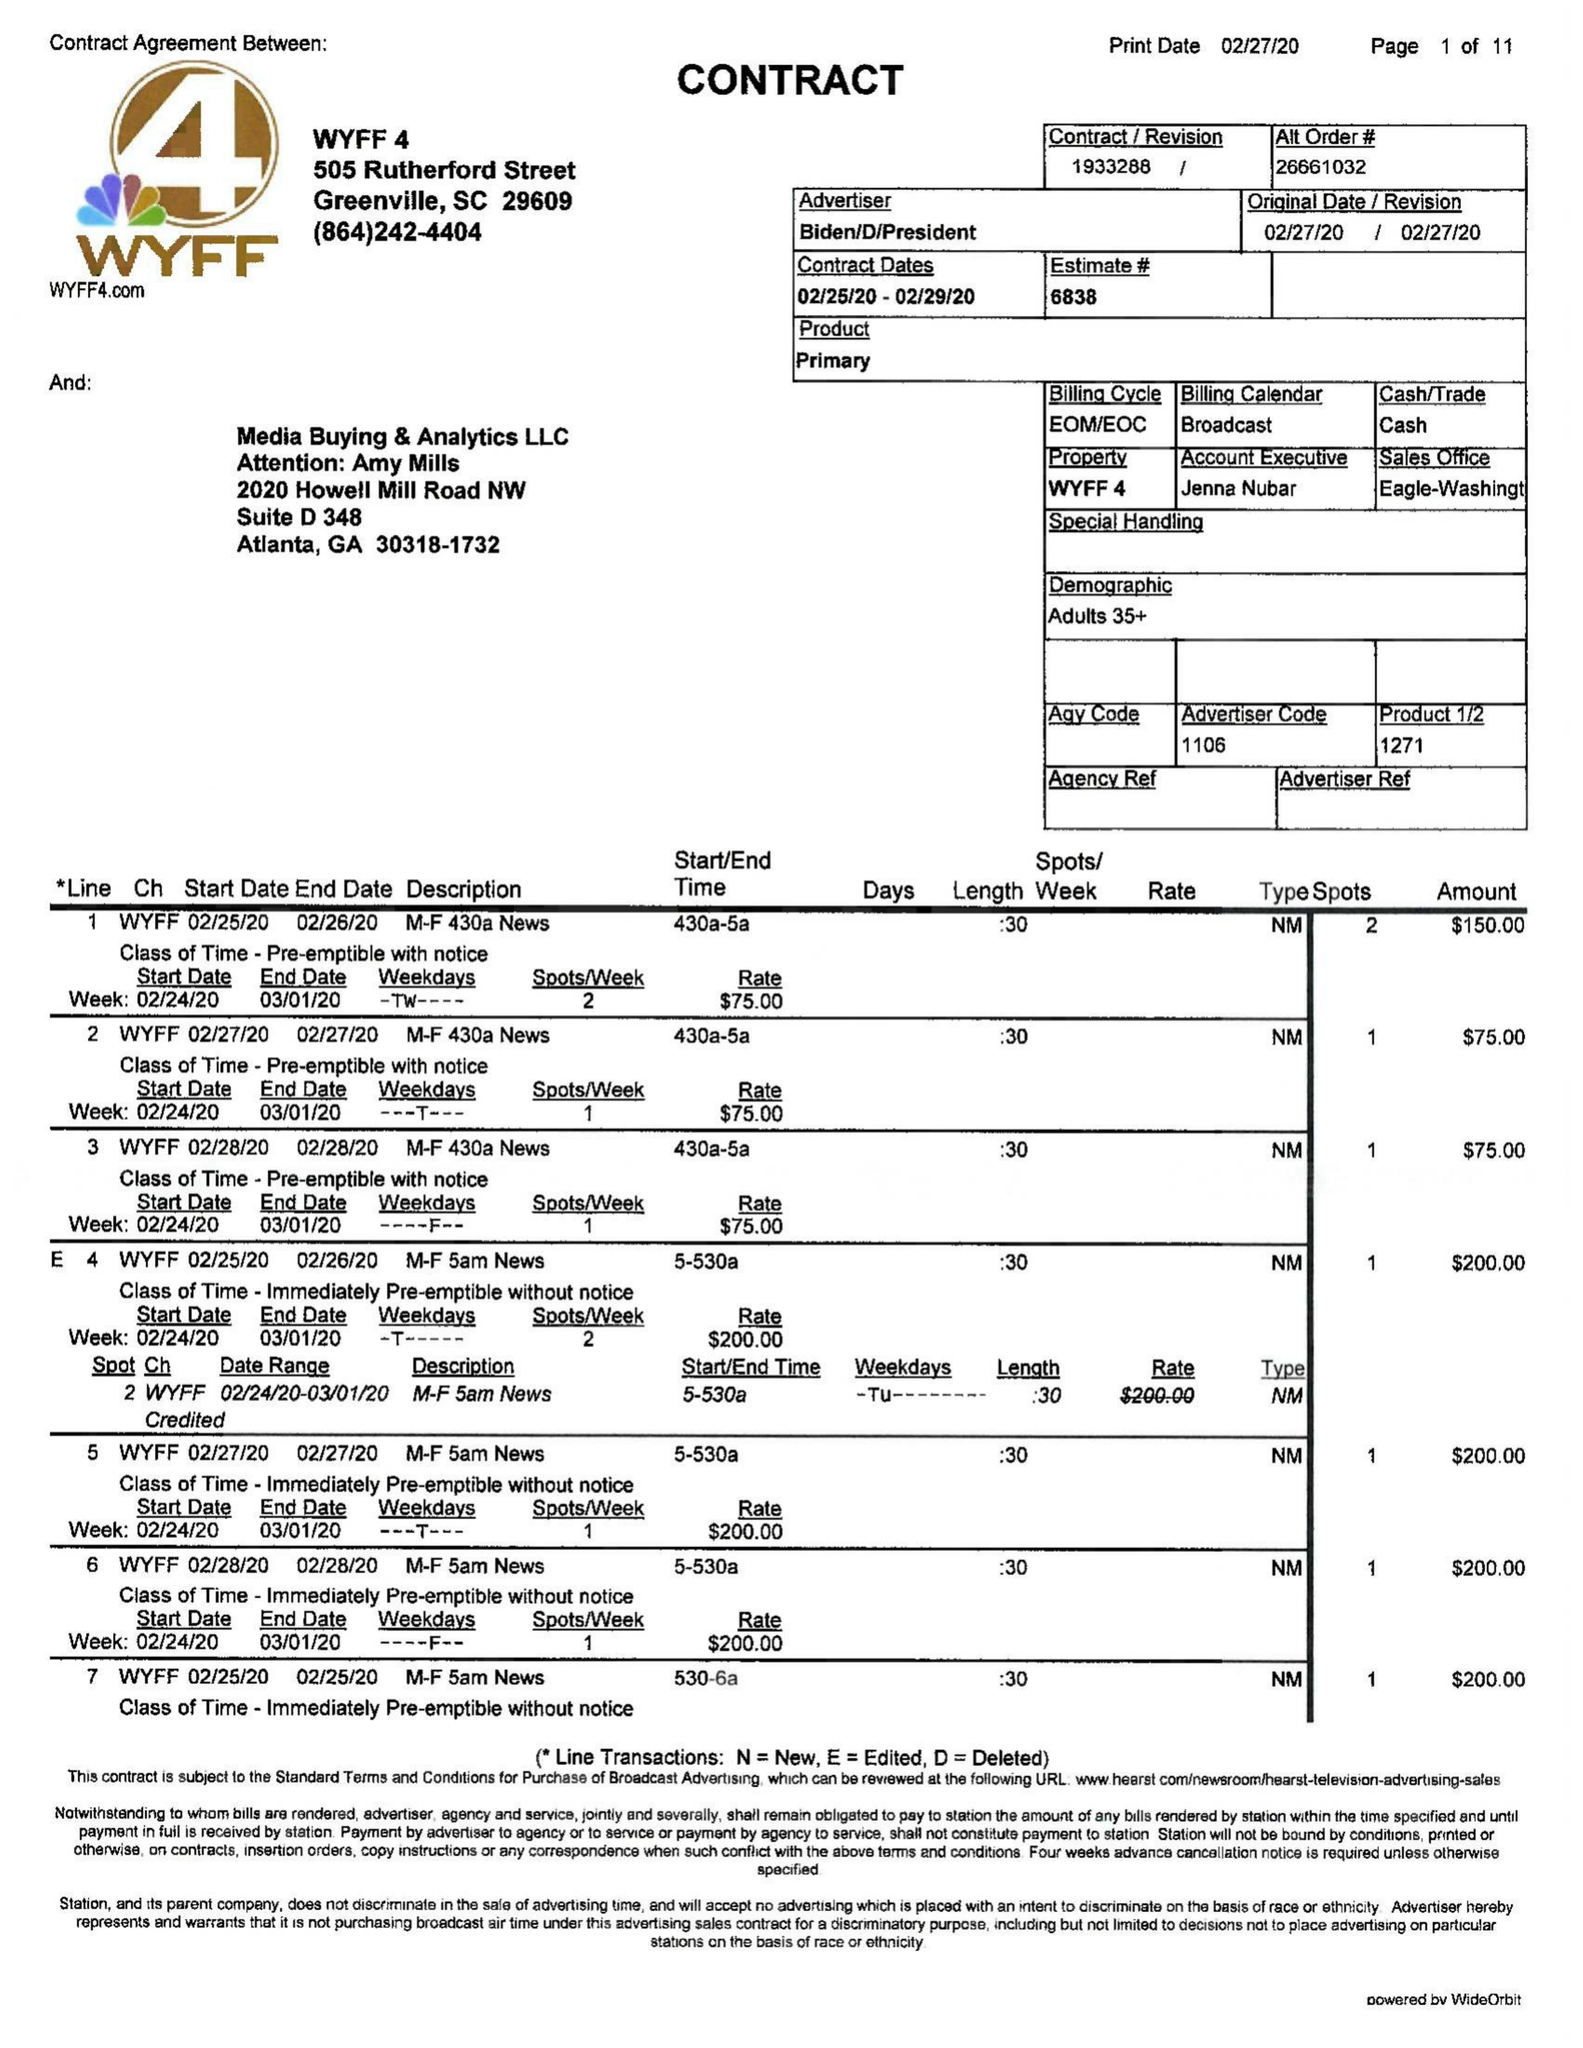What is the value for the contract_num?
Answer the question using a single word or phrase. 1933288 